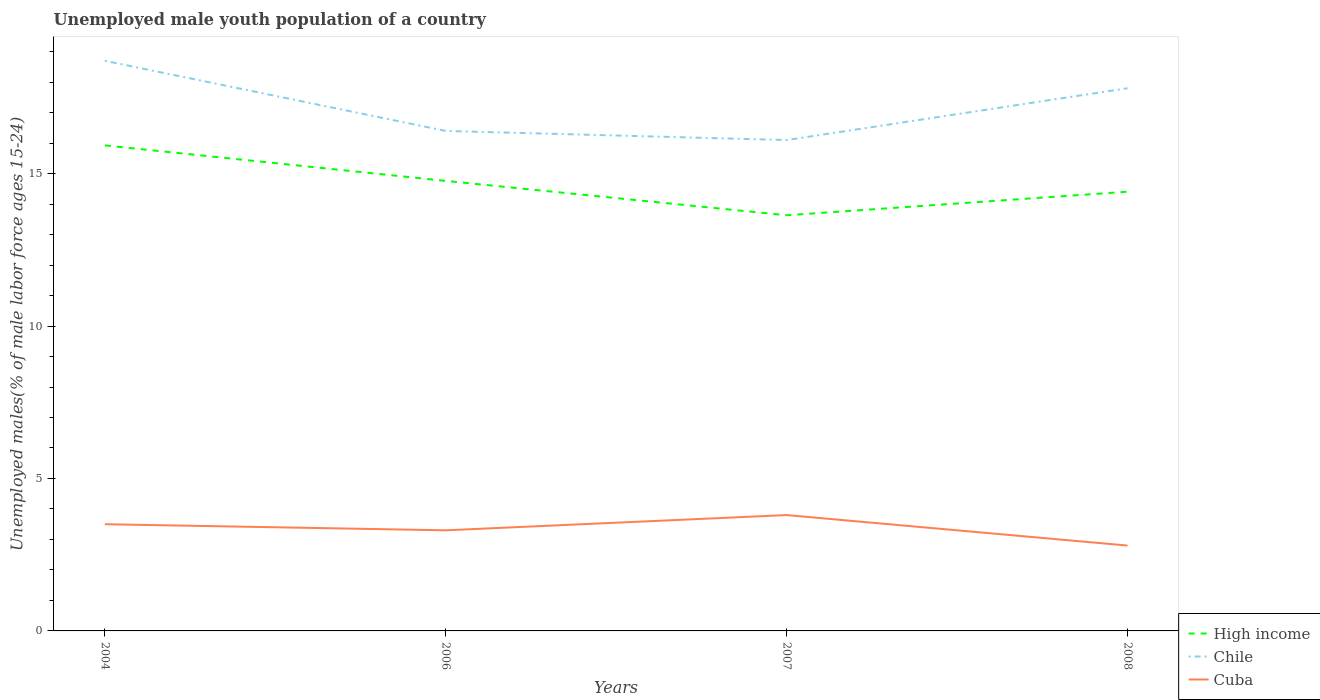How many different coloured lines are there?
Your answer should be compact. 3. Is the number of lines equal to the number of legend labels?
Give a very brief answer. Yes. Across all years, what is the maximum percentage of unemployed male youth population in Cuba?
Make the answer very short. 2.8. What is the total percentage of unemployed male youth population in High income in the graph?
Your response must be concise. 1.52. What is the difference between the highest and the second highest percentage of unemployed male youth population in High income?
Your response must be concise. 2.29. Is the percentage of unemployed male youth population in Cuba strictly greater than the percentage of unemployed male youth population in Chile over the years?
Ensure brevity in your answer.  Yes. How many lines are there?
Your answer should be very brief. 3. What is the difference between two consecutive major ticks on the Y-axis?
Your answer should be compact. 5. Are the values on the major ticks of Y-axis written in scientific E-notation?
Ensure brevity in your answer.  No. Does the graph contain grids?
Make the answer very short. No. How many legend labels are there?
Offer a terse response. 3. What is the title of the graph?
Give a very brief answer. Unemployed male youth population of a country. Does "Mexico" appear as one of the legend labels in the graph?
Your response must be concise. No. What is the label or title of the X-axis?
Provide a succinct answer. Years. What is the label or title of the Y-axis?
Give a very brief answer. Unemployed males(% of male labor force ages 15-24). What is the Unemployed males(% of male labor force ages 15-24) of High income in 2004?
Provide a succinct answer. 15.93. What is the Unemployed males(% of male labor force ages 15-24) of Chile in 2004?
Your answer should be very brief. 18.7. What is the Unemployed males(% of male labor force ages 15-24) of High income in 2006?
Your response must be concise. 14.76. What is the Unemployed males(% of male labor force ages 15-24) in Chile in 2006?
Offer a very short reply. 16.4. What is the Unemployed males(% of male labor force ages 15-24) in Cuba in 2006?
Make the answer very short. 3.3. What is the Unemployed males(% of male labor force ages 15-24) in High income in 2007?
Ensure brevity in your answer.  13.63. What is the Unemployed males(% of male labor force ages 15-24) in Chile in 2007?
Offer a very short reply. 16.1. What is the Unemployed males(% of male labor force ages 15-24) in Cuba in 2007?
Provide a succinct answer. 3.8. What is the Unemployed males(% of male labor force ages 15-24) in High income in 2008?
Provide a succinct answer. 14.41. What is the Unemployed males(% of male labor force ages 15-24) of Chile in 2008?
Provide a succinct answer. 17.8. What is the Unemployed males(% of male labor force ages 15-24) of Cuba in 2008?
Your answer should be very brief. 2.8. Across all years, what is the maximum Unemployed males(% of male labor force ages 15-24) of High income?
Make the answer very short. 15.93. Across all years, what is the maximum Unemployed males(% of male labor force ages 15-24) of Chile?
Give a very brief answer. 18.7. Across all years, what is the maximum Unemployed males(% of male labor force ages 15-24) of Cuba?
Make the answer very short. 3.8. Across all years, what is the minimum Unemployed males(% of male labor force ages 15-24) of High income?
Keep it short and to the point. 13.63. Across all years, what is the minimum Unemployed males(% of male labor force ages 15-24) in Chile?
Your response must be concise. 16.1. Across all years, what is the minimum Unemployed males(% of male labor force ages 15-24) of Cuba?
Provide a succinct answer. 2.8. What is the total Unemployed males(% of male labor force ages 15-24) in High income in the graph?
Your answer should be compact. 58.73. What is the total Unemployed males(% of male labor force ages 15-24) in Chile in the graph?
Provide a succinct answer. 69. What is the total Unemployed males(% of male labor force ages 15-24) of Cuba in the graph?
Make the answer very short. 13.4. What is the difference between the Unemployed males(% of male labor force ages 15-24) of High income in 2004 and that in 2006?
Ensure brevity in your answer.  1.16. What is the difference between the Unemployed males(% of male labor force ages 15-24) in Chile in 2004 and that in 2006?
Make the answer very short. 2.3. What is the difference between the Unemployed males(% of male labor force ages 15-24) of Cuba in 2004 and that in 2006?
Keep it short and to the point. 0.2. What is the difference between the Unemployed males(% of male labor force ages 15-24) in High income in 2004 and that in 2007?
Provide a succinct answer. 2.29. What is the difference between the Unemployed males(% of male labor force ages 15-24) of Cuba in 2004 and that in 2007?
Offer a terse response. -0.3. What is the difference between the Unemployed males(% of male labor force ages 15-24) in High income in 2004 and that in 2008?
Keep it short and to the point. 1.52. What is the difference between the Unemployed males(% of male labor force ages 15-24) of High income in 2006 and that in 2007?
Offer a very short reply. 1.13. What is the difference between the Unemployed males(% of male labor force ages 15-24) in Chile in 2006 and that in 2007?
Provide a succinct answer. 0.3. What is the difference between the Unemployed males(% of male labor force ages 15-24) of High income in 2006 and that in 2008?
Offer a very short reply. 0.35. What is the difference between the Unemployed males(% of male labor force ages 15-24) in High income in 2007 and that in 2008?
Ensure brevity in your answer.  -0.77. What is the difference between the Unemployed males(% of male labor force ages 15-24) in Chile in 2007 and that in 2008?
Keep it short and to the point. -1.7. What is the difference between the Unemployed males(% of male labor force ages 15-24) of Cuba in 2007 and that in 2008?
Provide a short and direct response. 1. What is the difference between the Unemployed males(% of male labor force ages 15-24) of High income in 2004 and the Unemployed males(% of male labor force ages 15-24) of Chile in 2006?
Make the answer very short. -0.47. What is the difference between the Unemployed males(% of male labor force ages 15-24) of High income in 2004 and the Unemployed males(% of male labor force ages 15-24) of Cuba in 2006?
Offer a very short reply. 12.63. What is the difference between the Unemployed males(% of male labor force ages 15-24) in High income in 2004 and the Unemployed males(% of male labor force ages 15-24) in Chile in 2007?
Your answer should be compact. -0.17. What is the difference between the Unemployed males(% of male labor force ages 15-24) in High income in 2004 and the Unemployed males(% of male labor force ages 15-24) in Cuba in 2007?
Ensure brevity in your answer.  12.13. What is the difference between the Unemployed males(% of male labor force ages 15-24) in Chile in 2004 and the Unemployed males(% of male labor force ages 15-24) in Cuba in 2007?
Your answer should be very brief. 14.9. What is the difference between the Unemployed males(% of male labor force ages 15-24) of High income in 2004 and the Unemployed males(% of male labor force ages 15-24) of Chile in 2008?
Ensure brevity in your answer.  -1.87. What is the difference between the Unemployed males(% of male labor force ages 15-24) of High income in 2004 and the Unemployed males(% of male labor force ages 15-24) of Cuba in 2008?
Give a very brief answer. 13.13. What is the difference between the Unemployed males(% of male labor force ages 15-24) of High income in 2006 and the Unemployed males(% of male labor force ages 15-24) of Chile in 2007?
Give a very brief answer. -1.34. What is the difference between the Unemployed males(% of male labor force ages 15-24) in High income in 2006 and the Unemployed males(% of male labor force ages 15-24) in Cuba in 2007?
Provide a short and direct response. 10.96. What is the difference between the Unemployed males(% of male labor force ages 15-24) in Chile in 2006 and the Unemployed males(% of male labor force ages 15-24) in Cuba in 2007?
Your answer should be very brief. 12.6. What is the difference between the Unemployed males(% of male labor force ages 15-24) of High income in 2006 and the Unemployed males(% of male labor force ages 15-24) of Chile in 2008?
Offer a very short reply. -3.04. What is the difference between the Unemployed males(% of male labor force ages 15-24) of High income in 2006 and the Unemployed males(% of male labor force ages 15-24) of Cuba in 2008?
Ensure brevity in your answer.  11.96. What is the difference between the Unemployed males(% of male labor force ages 15-24) in High income in 2007 and the Unemployed males(% of male labor force ages 15-24) in Chile in 2008?
Make the answer very short. -4.17. What is the difference between the Unemployed males(% of male labor force ages 15-24) of High income in 2007 and the Unemployed males(% of male labor force ages 15-24) of Cuba in 2008?
Your answer should be compact. 10.83. What is the difference between the Unemployed males(% of male labor force ages 15-24) in Chile in 2007 and the Unemployed males(% of male labor force ages 15-24) in Cuba in 2008?
Offer a very short reply. 13.3. What is the average Unemployed males(% of male labor force ages 15-24) of High income per year?
Offer a terse response. 14.68. What is the average Unemployed males(% of male labor force ages 15-24) in Chile per year?
Provide a short and direct response. 17.25. What is the average Unemployed males(% of male labor force ages 15-24) of Cuba per year?
Ensure brevity in your answer.  3.35. In the year 2004, what is the difference between the Unemployed males(% of male labor force ages 15-24) of High income and Unemployed males(% of male labor force ages 15-24) of Chile?
Offer a terse response. -2.77. In the year 2004, what is the difference between the Unemployed males(% of male labor force ages 15-24) of High income and Unemployed males(% of male labor force ages 15-24) of Cuba?
Your answer should be compact. 12.43. In the year 2006, what is the difference between the Unemployed males(% of male labor force ages 15-24) of High income and Unemployed males(% of male labor force ages 15-24) of Chile?
Offer a terse response. -1.64. In the year 2006, what is the difference between the Unemployed males(% of male labor force ages 15-24) of High income and Unemployed males(% of male labor force ages 15-24) of Cuba?
Your answer should be very brief. 11.46. In the year 2007, what is the difference between the Unemployed males(% of male labor force ages 15-24) of High income and Unemployed males(% of male labor force ages 15-24) of Chile?
Ensure brevity in your answer.  -2.47. In the year 2007, what is the difference between the Unemployed males(% of male labor force ages 15-24) of High income and Unemployed males(% of male labor force ages 15-24) of Cuba?
Give a very brief answer. 9.83. In the year 2007, what is the difference between the Unemployed males(% of male labor force ages 15-24) of Chile and Unemployed males(% of male labor force ages 15-24) of Cuba?
Your answer should be very brief. 12.3. In the year 2008, what is the difference between the Unemployed males(% of male labor force ages 15-24) in High income and Unemployed males(% of male labor force ages 15-24) in Chile?
Offer a terse response. -3.39. In the year 2008, what is the difference between the Unemployed males(% of male labor force ages 15-24) in High income and Unemployed males(% of male labor force ages 15-24) in Cuba?
Make the answer very short. 11.61. In the year 2008, what is the difference between the Unemployed males(% of male labor force ages 15-24) of Chile and Unemployed males(% of male labor force ages 15-24) of Cuba?
Keep it short and to the point. 15. What is the ratio of the Unemployed males(% of male labor force ages 15-24) of High income in 2004 to that in 2006?
Make the answer very short. 1.08. What is the ratio of the Unemployed males(% of male labor force ages 15-24) in Chile in 2004 to that in 2006?
Give a very brief answer. 1.14. What is the ratio of the Unemployed males(% of male labor force ages 15-24) in Cuba in 2004 to that in 2006?
Your answer should be compact. 1.06. What is the ratio of the Unemployed males(% of male labor force ages 15-24) of High income in 2004 to that in 2007?
Your response must be concise. 1.17. What is the ratio of the Unemployed males(% of male labor force ages 15-24) of Chile in 2004 to that in 2007?
Offer a terse response. 1.16. What is the ratio of the Unemployed males(% of male labor force ages 15-24) of Cuba in 2004 to that in 2007?
Your answer should be compact. 0.92. What is the ratio of the Unemployed males(% of male labor force ages 15-24) of High income in 2004 to that in 2008?
Your response must be concise. 1.11. What is the ratio of the Unemployed males(% of male labor force ages 15-24) in Chile in 2004 to that in 2008?
Keep it short and to the point. 1.05. What is the ratio of the Unemployed males(% of male labor force ages 15-24) in High income in 2006 to that in 2007?
Provide a succinct answer. 1.08. What is the ratio of the Unemployed males(% of male labor force ages 15-24) of Chile in 2006 to that in 2007?
Offer a very short reply. 1.02. What is the ratio of the Unemployed males(% of male labor force ages 15-24) of Cuba in 2006 to that in 2007?
Your answer should be compact. 0.87. What is the ratio of the Unemployed males(% of male labor force ages 15-24) of High income in 2006 to that in 2008?
Give a very brief answer. 1.02. What is the ratio of the Unemployed males(% of male labor force ages 15-24) of Chile in 2006 to that in 2008?
Offer a terse response. 0.92. What is the ratio of the Unemployed males(% of male labor force ages 15-24) in Cuba in 2006 to that in 2008?
Keep it short and to the point. 1.18. What is the ratio of the Unemployed males(% of male labor force ages 15-24) in High income in 2007 to that in 2008?
Offer a terse response. 0.95. What is the ratio of the Unemployed males(% of male labor force ages 15-24) in Chile in 2007 to that in 2008?
Offer a very short reply. 0.9. What is the ratio of the Unemployed males(% of male labor force ages 15-24) in Cuba in 2007 to that in 2008?
Keep it short and to the point. 1.36. What is the difference between the highest and the second highest Unemployed males(% of male labor force ages 15-24) of High income?
Provide a succinct answer. 1.16. What is the difference between the highest and the second highest Unemployed males(% of male labor force ages 15-24) in Cuba?
Ensure brevity in your answer.  0.3. What is the difference between the highest and the lowest Unemployed males(% of male labor force ages 15-24) of High income?
Your answer should be compact. 2.29. What is the difference between the highest and the lowest Unemployed males(% of male labor force ages 15-24) of Chile?
Give a very brief answer. 2.6. What is the difference between the highest and the lowest Unemployed males(% of male labor force ages 15-24) of Cuba?
Ensure brevity in your answer.  1. 